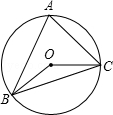First perform reasoning, then finally select the question from the choices in the following format: Answer: xxx.
Question: In the given figure, triangle ABC is inscribed in circle O with angle A measuring 60.0 degrees. Determine the measure of angle BOC, denoted as θ.
Choices:
A: 30°
B: 120°
C: 110°
D: 100° Renowned for its fundamental properties, an inscribed angle in a circle is half the measure of its intercepted arc. Since angle A intercepts arc BC, the central angle of the opposite arc is BOC. By applying the property that the measure of a central angle is twice the measure of its corresponding inscribed angle, we get θ = 2 * 60° = 120°. Hence, the measure of angle BOC is 120.0 degrees, therefore the answer is option B.
Answer:B 